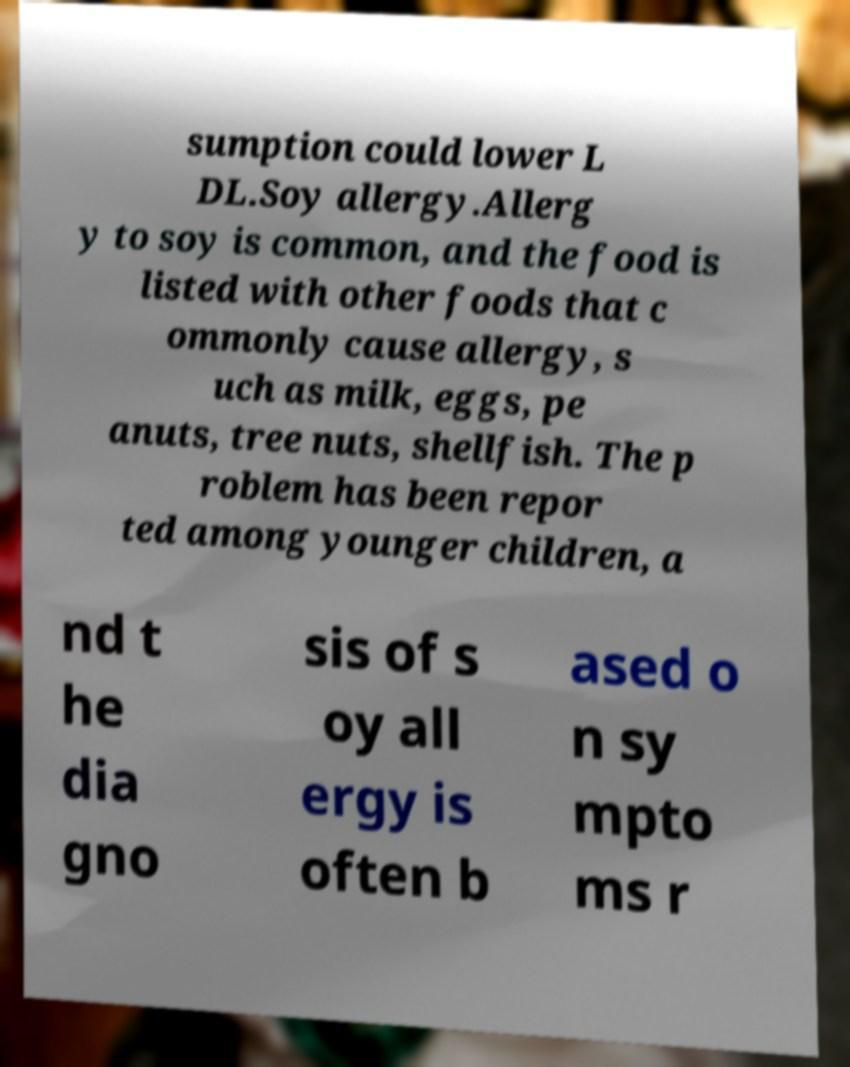Could you assist in decoding the text presented in this image and type it out clearly? sumption could lower L DL.Soy allergy.Allerg y to soy is common, and the food is listed with other foods that c ommonly cause allergy, s uch as milk, eggs, pe anuts, tree nuts, shellfish. The p roblem has been repor ted among younger children, a nd t he dia gno sis of s oy all ergy is often b ased o n sy mpto ms r 